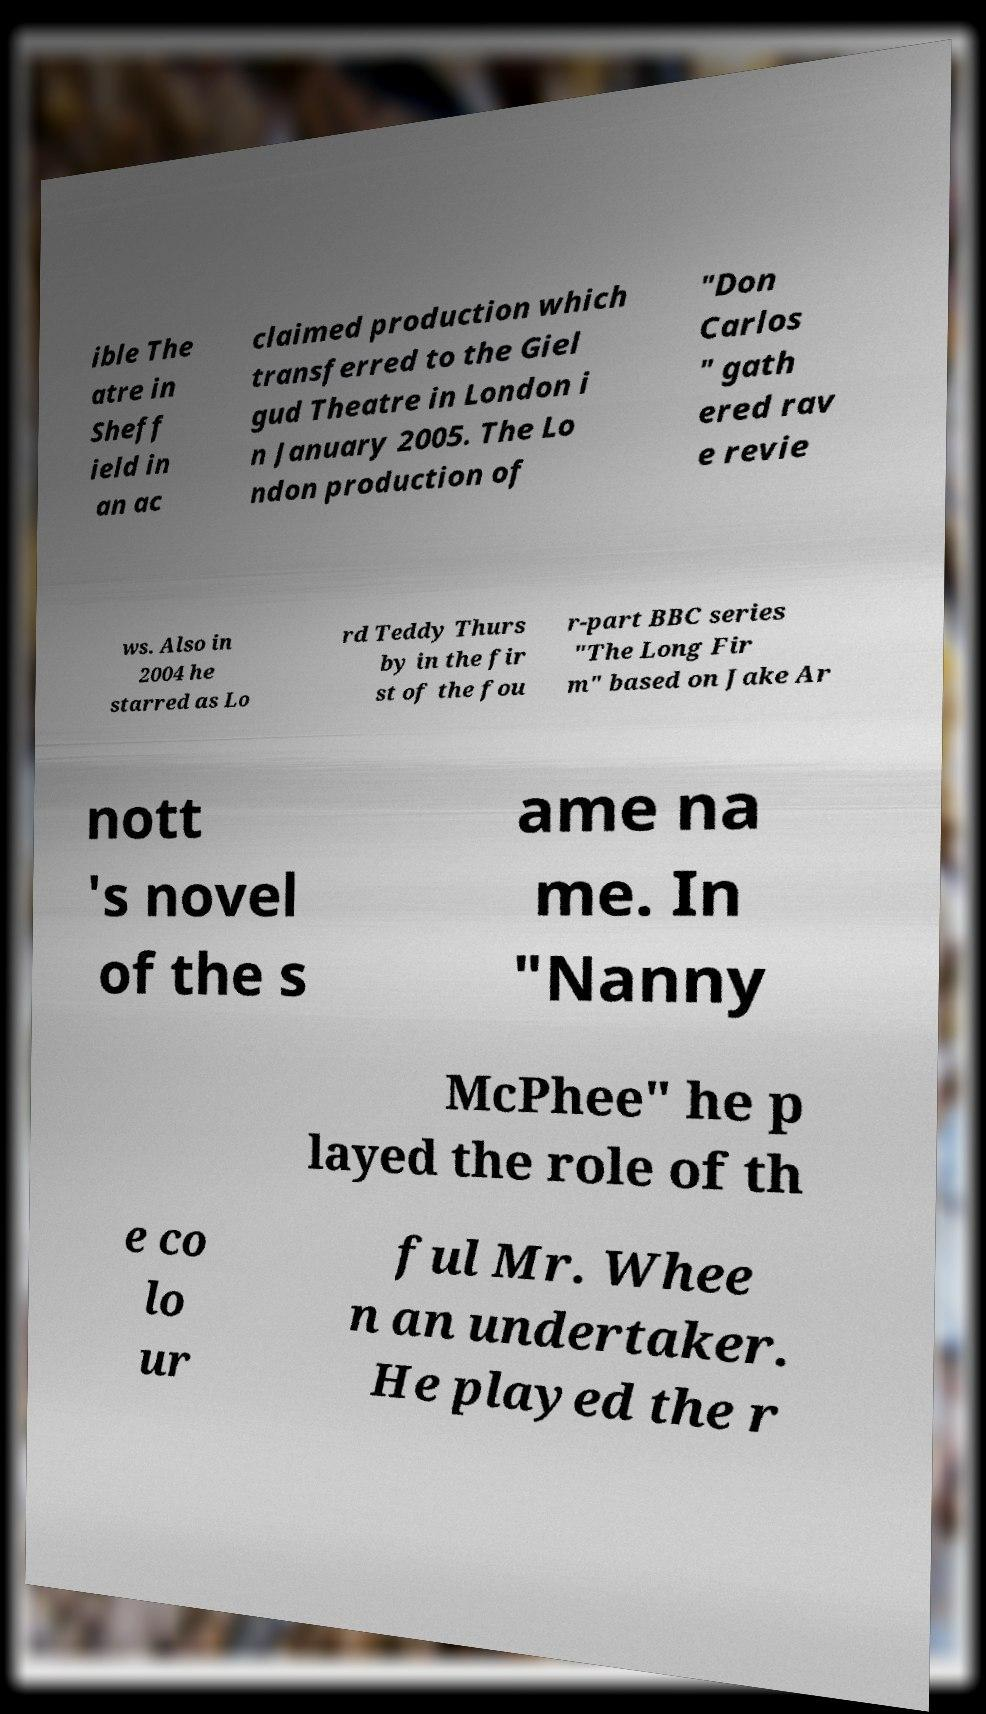Could you extract and type out the text from this image? ible The atre in Sheff ield in an ac claimed production which transferred to the Giel gud Theatre in London i n January 2005. The Lo ndon production of "Don Carlos " gath ered rav e revie ws. Also in 2004 he starred as Lo rd Teddy Thurs by in the fir st of the fou r-part BBC series "The Long Fir m" based on Jake Ar nott 's novel of the s ame na me. In "Nanny McPhee" he p layed the role of th e co lo ur ful Mr. Whee n an undertaker. He played the r 